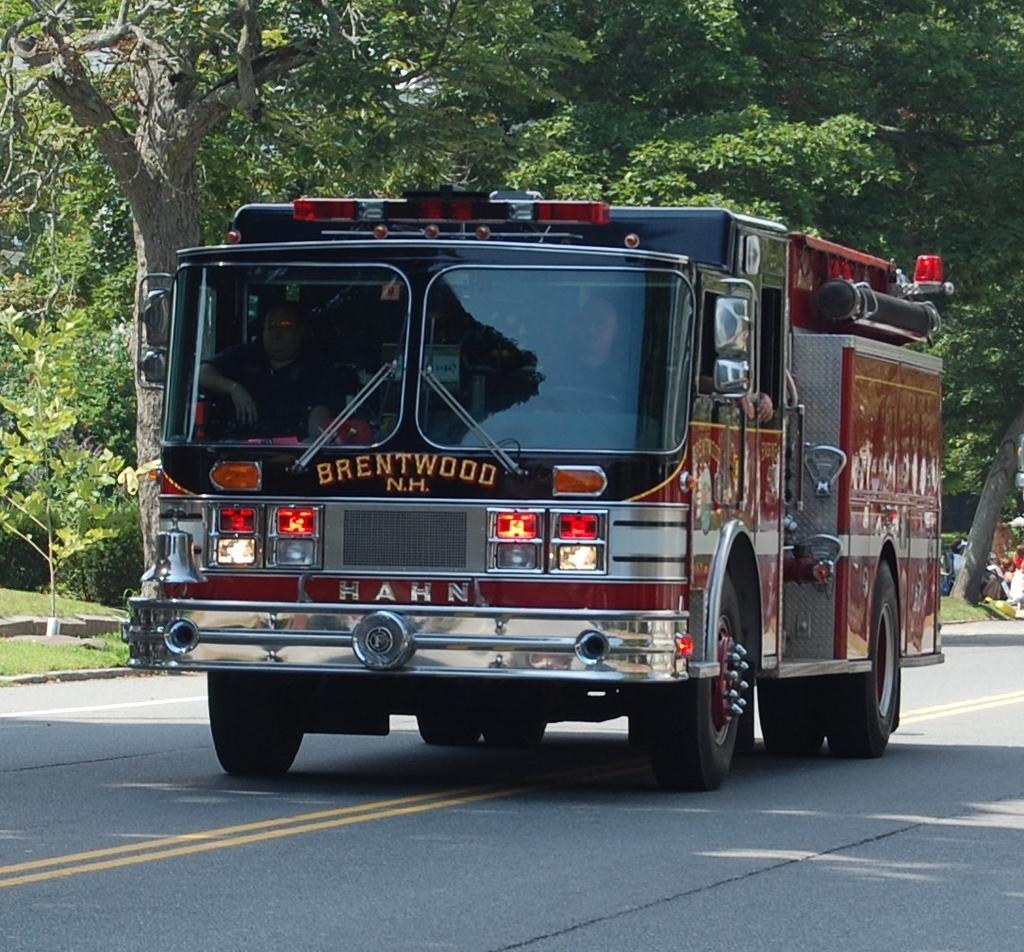Could you give a brief overview of what you see in this image? This image is clicked on the road. There is a truck moving on the road. There is text on the truck. Beside the road there's grass on the ground. In the background there are trees. There are people sitting inside the truck. 